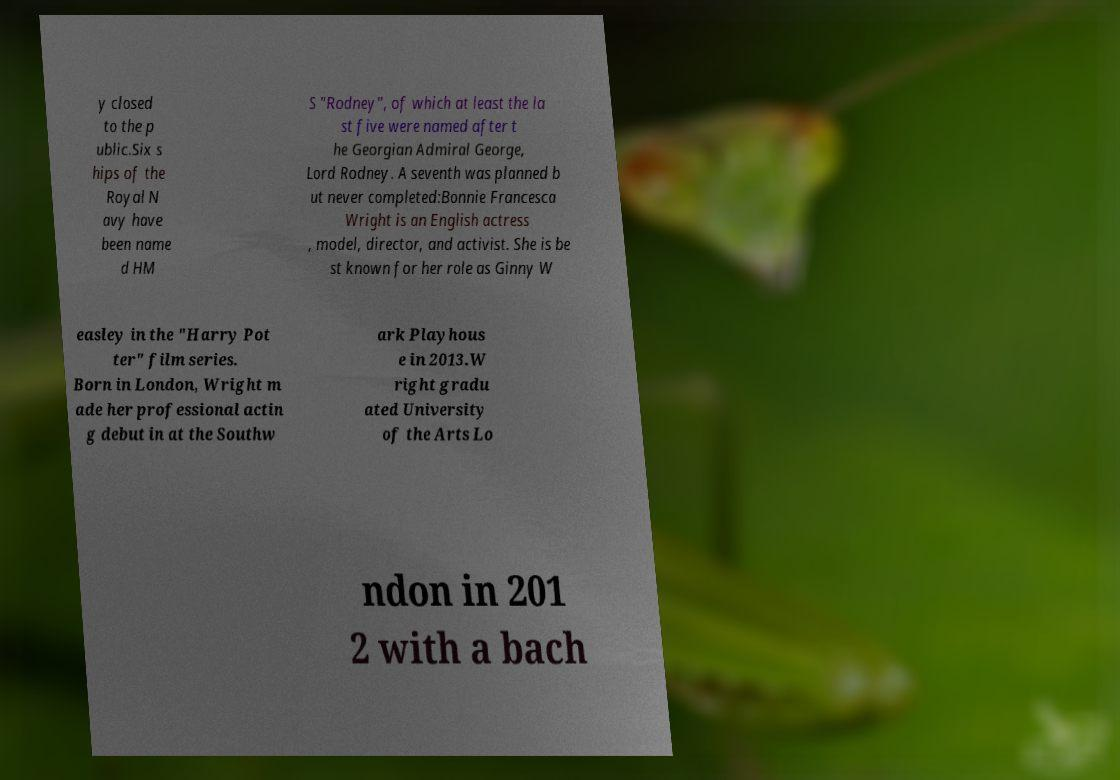Could you assist in decoding the text presented in this image and type it out clearly? y closed to the p ublic.Six s hips of the Royal N avy have been name d HM S "Rodney", of which at least the la st five were named after t he Georgian Admiral George, Lord Rodney. A seventh was planned b ut never completed:Bonnie Francesca Wright is an English actress , model, director, and activist. She is be st known for her role as Ginny W easley in the "Harry Pot ter" film series. Born in London, Wright m ade her professional actin g debut in at the Southw ark Playhous e in 2013.W right gradu ated University of the Arts Lo ndon in 201 2 with a bach 